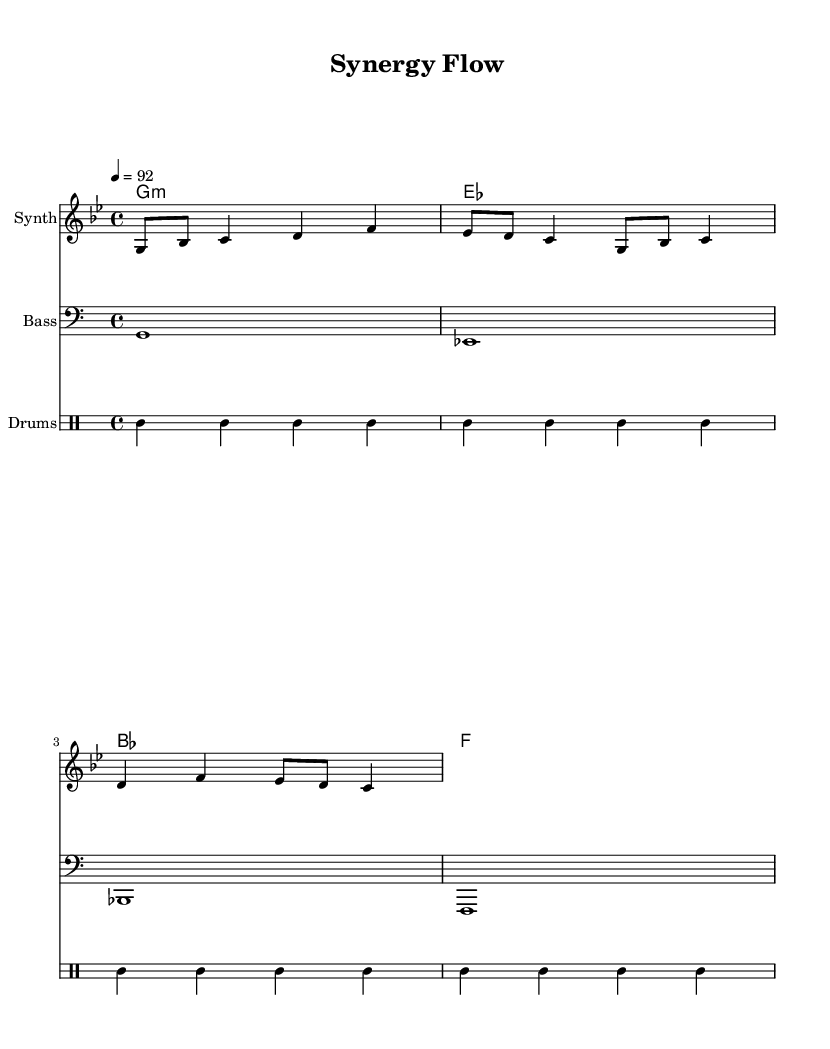What is the key signature of this music? The key signature is G minor, which has two flats (B and E). This can be identified at the beginning of the staff where the flats are placed.
Answer: G minor What is the time signature of this piece? The time signature indicated is 4/4, which is shown at the beginning of the music. This means there are four beats in each measure.
Answer: 4/4 What is the tempo marking for this score? The tempo marking is 92 beats per minute, which is set in the tempo indication at the beginning of the piece.
Answer: 92 How many measures are in the melody? The melody consists of four measures as can be observed from the melody notation, with each measure delineated by vertical bar lines.
Answer: 4 What instrument is labeled as "Synth"? The labeled instrument "Synth" refers to the staff where the melody is composed, indicating it is meant to be played on a synthesizer.
Answer: Synth What is the rhythm pattern of the drums? The rhythm pattern of the drums alternates between a bass drum and snare with hi-hat hits in between, which can be seen in the drummode section.
Answer: Bass and snare What genre of music does this piece represent? This piece represents the genre of Rap, evidenced by its upbeat tempo and the thematic connection to collaboration and celebration within departments, typical characteristics of hip-hop anthems.
Answer: Rap 